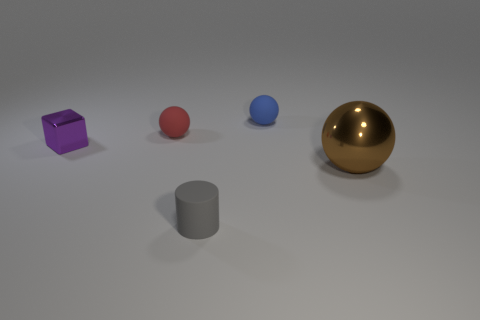Subtract all matte balls. How many balls are left? 1 Subtract all brown balls. How many balls are left? 2 Add 1 small purple metal blocks. How many objects exist? 6 Subtract 2 balls. How many balls are left? 1 Subtract all gray spheres. Subtract all blue cubes. How many spheres are left? 3 Subtract all gray cubes. How many cyan balls are left? 0 Subtract all red rubber objects. Subtract all blue things. How many objects are left? 3 Add 2 big metallic spheres. How many big metallic spheres are left? 3 Add 5 small red spheres. How many small red spheres exist? 6 Subtract 0 cyan spheres. How many objects are left? 5 